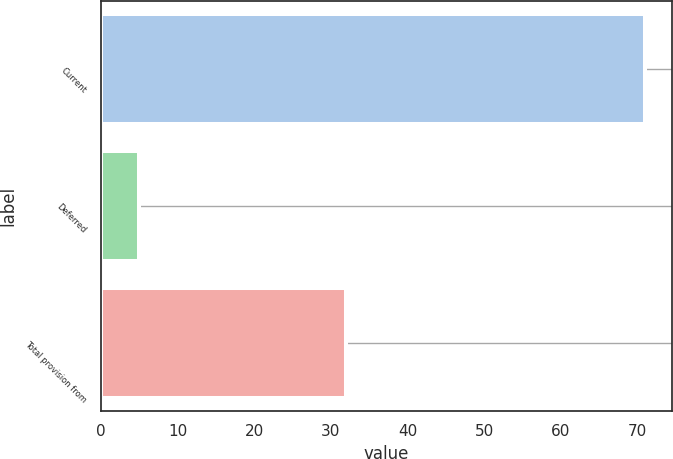Convert chart. <chart><loc_0><loc_0><loc_500><loc_500><bar_chart><fcel>Current<fcel>Deferred<fcel>Total provision from<nl><fcel>71<fcel>5<fcel>32<nl></chart> 